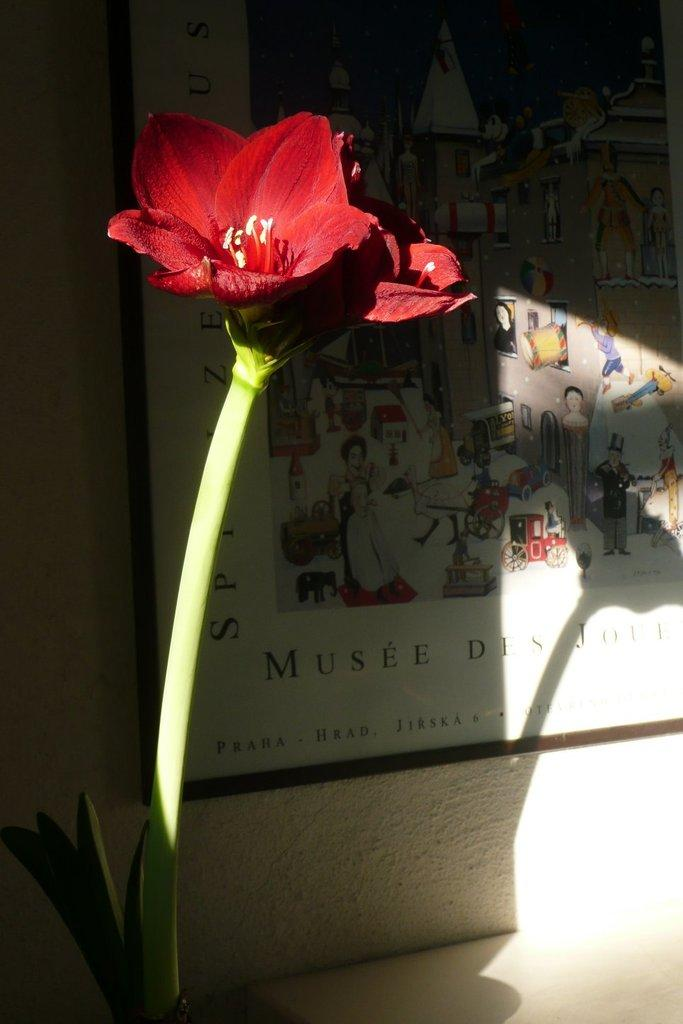What type of plants are in the image? There are flowers with stems in the image. What can be seen in the background of the image? There is a photo frame in the background of the image. How is the photo frame positioned in the image? The photo frame is attached to the wall. What type of coat can be seen hanging on the wall in the image? There is no coat present in the image; it only features flowers with stems and a photo frame attached to the wall. 